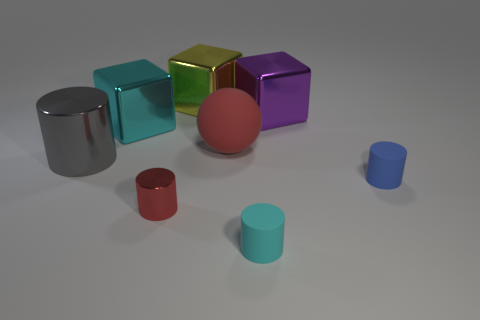The tiny metallic cylinder has what color?
Your answer should be compact. Red. Is there a metallic block behind the large block on the right side of the large red rubber sphere?
Your answer should be compact. Yes. How many other shiny cylinders are the same size as the cyan cylinder?
Your response must be concise. 1. There is a small object behind the tiny thing that is to the left of the small cyan rubber object; how many purple things are behind it?
Your answer should be compact. 1. How many objects are both to the left of the big purple thing and in front of the large yellow shiny thing?
Offer a very short reply. 5. Are there any other things that have the same color as the large sphere?
Offer a very short reply. Yes. How many matte things are tiny green spheres or large cylinders?
Make the answer very short. 0. What material is the cyan object that is behind the matte cylinder behind the red thing that is in front of the blue matte cylinder?
Offer a very short reply. Metal. What material is the large block that is to the right of the red thing that is behind the large gray shiny thing?
Ensure brevity in your answer.  Metal. Do the cyan object on the right side of the matte sphere and the red metal cylinder that is right of the gray cylinder have the same size?
Make the answer very short. Yes. 